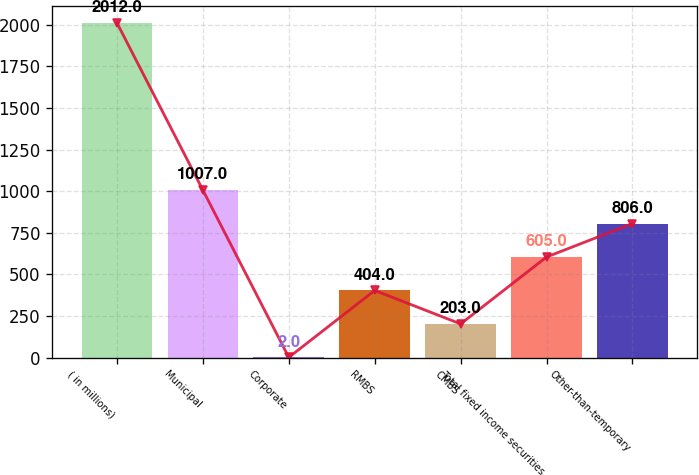<chart> <loc_0><loc_0><loc_500><loc_500><bar_chart><fcel>( in millions)<fcel>Municipal<fcel>Corporate<fcel>RMBS<fcel>CMBS<fcel>Total fixed income securities<fcel>Other-than-temporary<nl><fcel>2012<fcel>1007<fcel>2<fcel>404<fcel>203<fcel>605<fcel>806<nl></chart> 